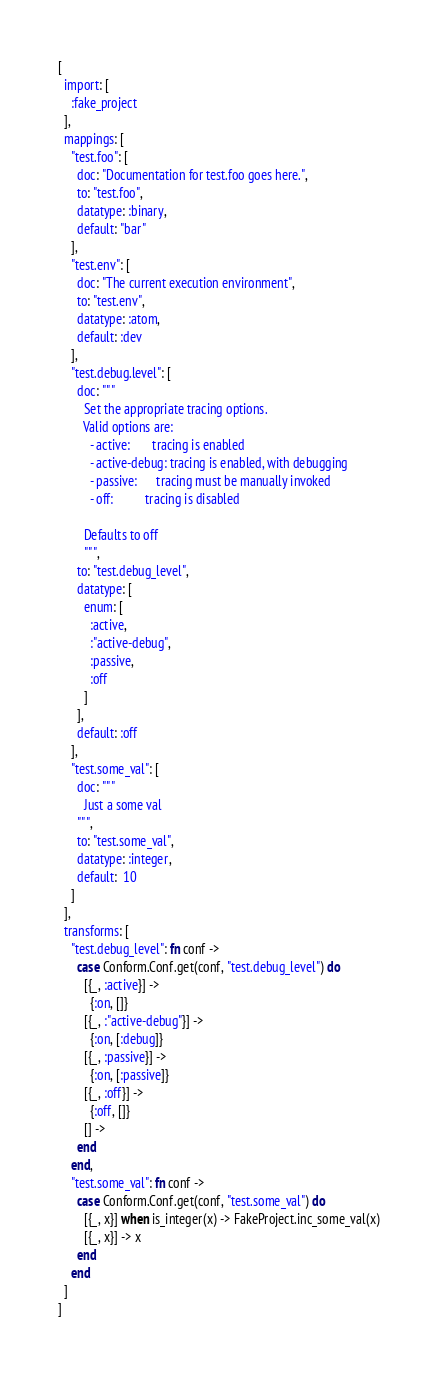Convert code to text. <code><loc_0><loc_0><loc_500><loc_500><_Elixir_>[
  import: [
    :fake_project
  ],
  mappings: [
    "test.foo": [
      doc: "Documentation for test.foo goes here.",
      to: "test.foo",
      datatype: :binary,
      default: "bar"
    ],
    "test.env": [
      doc: "The current execution environment",
      to: "test.env",
      datatype: :atom,
      default: :dev
    ],
    "test.debug.level": [
      doc: """
        Set the appropriate tracing options.
        Valid options are:
          - active:       tracing is enabled
          - active-debug: tracing is enabled, with debugging
          - passive:      tracing must be manually invoked
          - off:          tracing is disabled

        Defaults to off
        """,
      to: "test.debug_level",
      datatype: [
        enum: [
          :active,
          :"active-debug",
          :passive,
          :off
        ]
      ],
      default: :off
    ],
    "test.some_val": [
      doc: """
        Just a some val
      """,
      to: "test.some_val",
      datatype: :integer,
      default:  10
    ]
  ],
  transforms: [
    "test.debug_level": fn conf ->
      case Conform.Conf.get(conf, "test.debug_level") do
        [{_, :active}] ->
          {:on, []}
        [{_, :"active-debug"}] ->
          {:on, [:debug]}
        [{_, :passive}] ->
          {:on, [:passive]}
        [{_, :off}] ->
          {:off, []}
        [] ->
      end
    end,
    "test.some_val": fn conf ->
      case Conform.Conf.get(conf, "test.some_val") do
        [{_, x}] when is_integer(x) -> FakeProject.inc_some_val(x)
        [{_, x}] -> x
      end
    end
  ]
]
</code> 